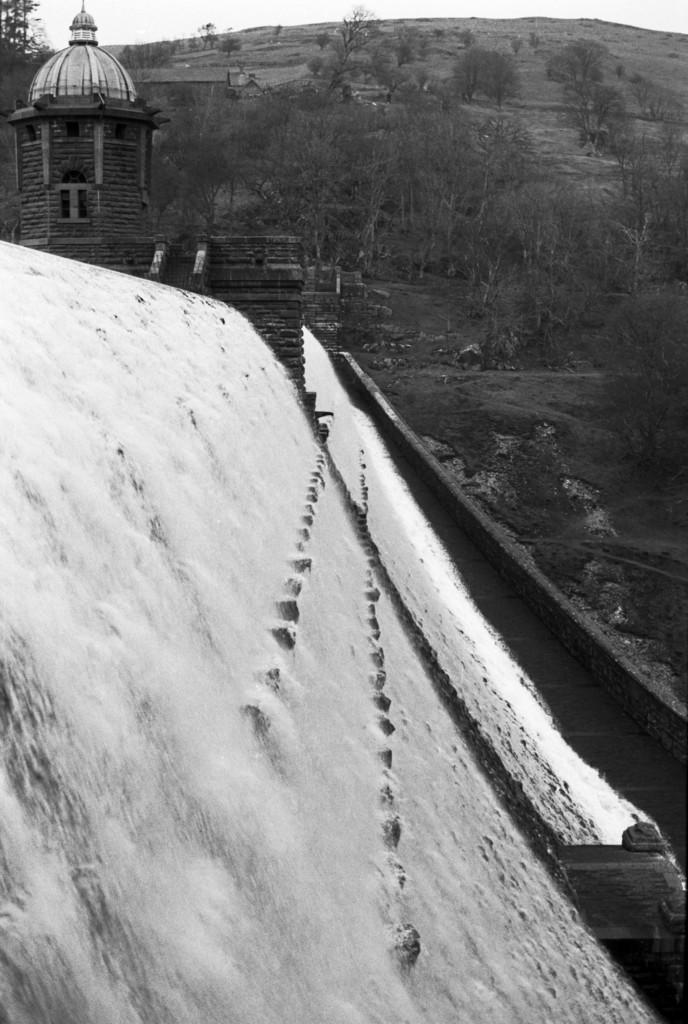What natural feature is the main subject of the image? There is a waterfall in the image. What structure can be seen on the left side of the image? There is a dome on the left side of the image. What type of vegetation is visible in the background of the image? There are trees in the background of the image. What part of the natural environment is visible in the background of the image? The sky is visible in the background of the image. What type of celery can be seen growing near the waterfall in the image? There is no celery present in the image; it is a waterfall with a dome and trees in the background. How does the waterfall say good-bye to the dome in the image? The waterfall and dome are inanimate objects and do not have the ability to say good-bye. 